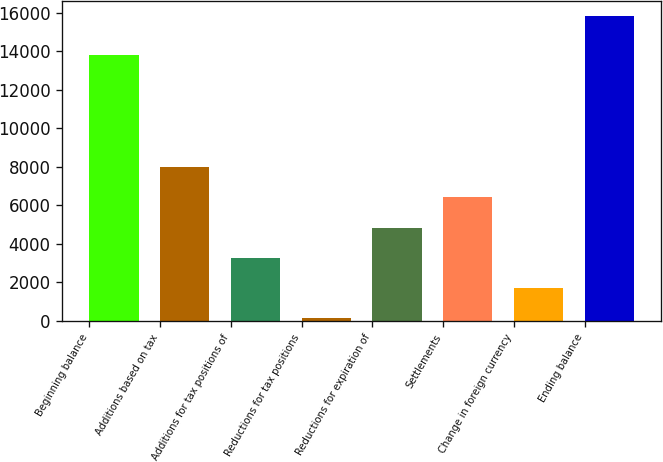Convert chart. <chart><loc_0><loc_0><loc_500><loc_500><bar_chart><fcel>Beginning balance<fcel>Additions based on tax<fcel>Additions for tax positions of<fcel>Reductions for tax positions<fcel>Reductions for expiration of<fcel>Settlements<fcel>Change in foreign currency<fcel>Ending balance<nl><fcel>13804<fcel>7980.5<fcel>3274.4<fcel>137<fcel>4843.1<fcel>6411.8<fcel>1705.7<fcel>15824<nl></chart> 